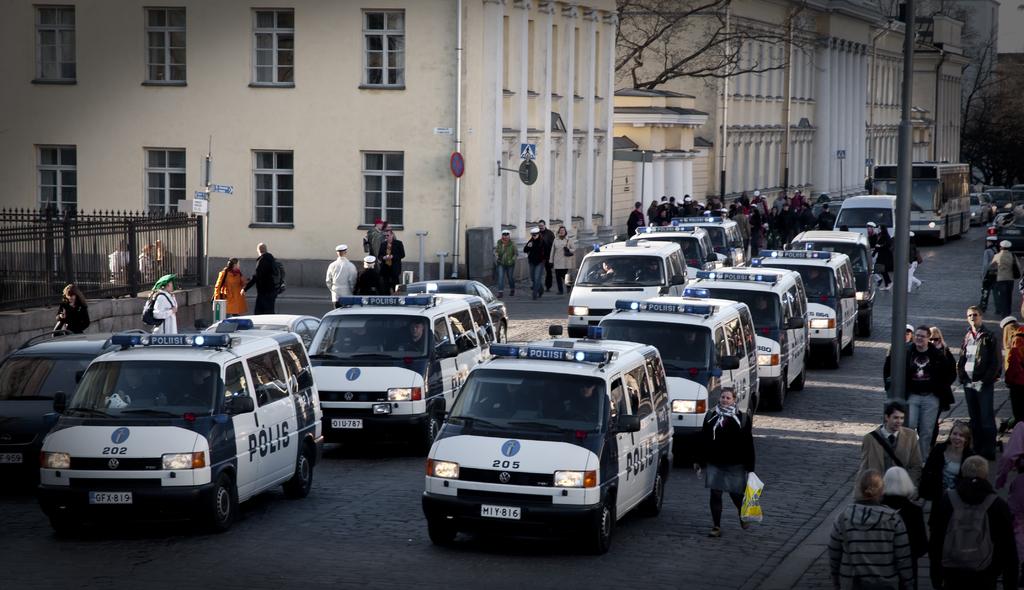What number is the van on the front right?
Your answer should be very brief. 205. Which department are these vehicles for?
Give a very brief answer. Police. 